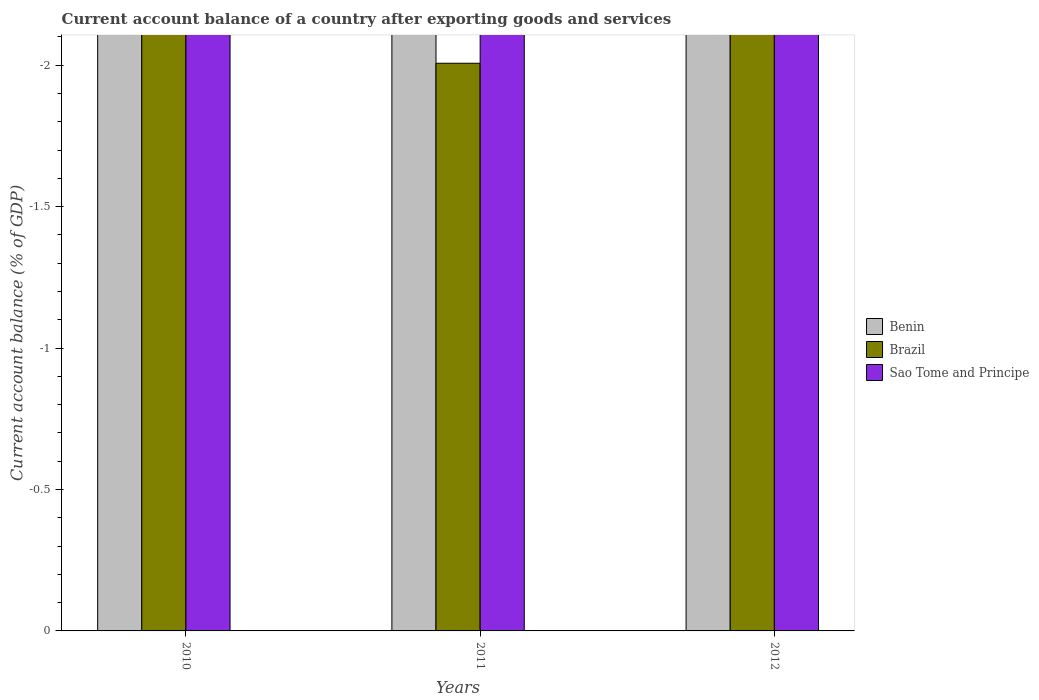What is the label of the 3rd group of bars from the left?
Keep it short and to the point. 2012. What is the account balance in Brazil in 2011?
Provide a succinct answer. 0. What is the average account balance in Sao Tome and Principe per year?
Your response must be concise. 0. In how many years, is the account balance in Benin greater than -1.9 %?
Provide a short and direct response. 0. How many years are there in the graph?
Provide a succinct answer. 3. What is the difference between two consecutive major ticks on the Y-axis?
Your answer should be very brief. 0.5. Are the values on the major ticks of Y-axis written in scientific E-notation?
Your answer should be very brief. No. Does the graph contain any zero values?
Provide a short and direct response. Yes. Does the graph contain grids?
Keep it short and to the point. No. Where does the legend appear in the graph?
Make the answer very short. Center right. How many legend labels are there?
Keep it short and to the point. 3. How are the legend labels stacked?
Provide a short and direct response. Vertical. What is the title of the graph?
Your answer should be compact. Current account balance of a country after exporting goods and services. Does "New Zealand" appear as one of the legend labels in the graph?
Offer a terse response. No. What is the label or title of the Y-axis?
Offer a terse response. Current account balance (% of GDP). What is the Current account balance (% of GDP) of Brazil in 2010?
Provide a short and direct response. 0. What is the Current account balance (% of GDP) in Brazil in 2011?
Make the answer very short. 0. What is the Current account balance (% of GDP) of Benin in 2012?
Ensure brevity in your answer.  0. What is the Current account balance (% of GDP) in Brazil in 2012?
Give a very brief answer. 0. What is the total Current account balance (% of GDP) of Benin in the graph?
Ensure brevity in your answer.  0. What is the total Current account balance (% of GDP) of Sao Tome and Principe in the graph?
Your answer should be compact. 0. What is the average Current account balance (% of GDP) of Brazil per year?
Offer a terse response. 0. What is the average Current account balance (% of GDP) in Sao Tome and Principe per year?
Ensure brevity in your answer.  0. 